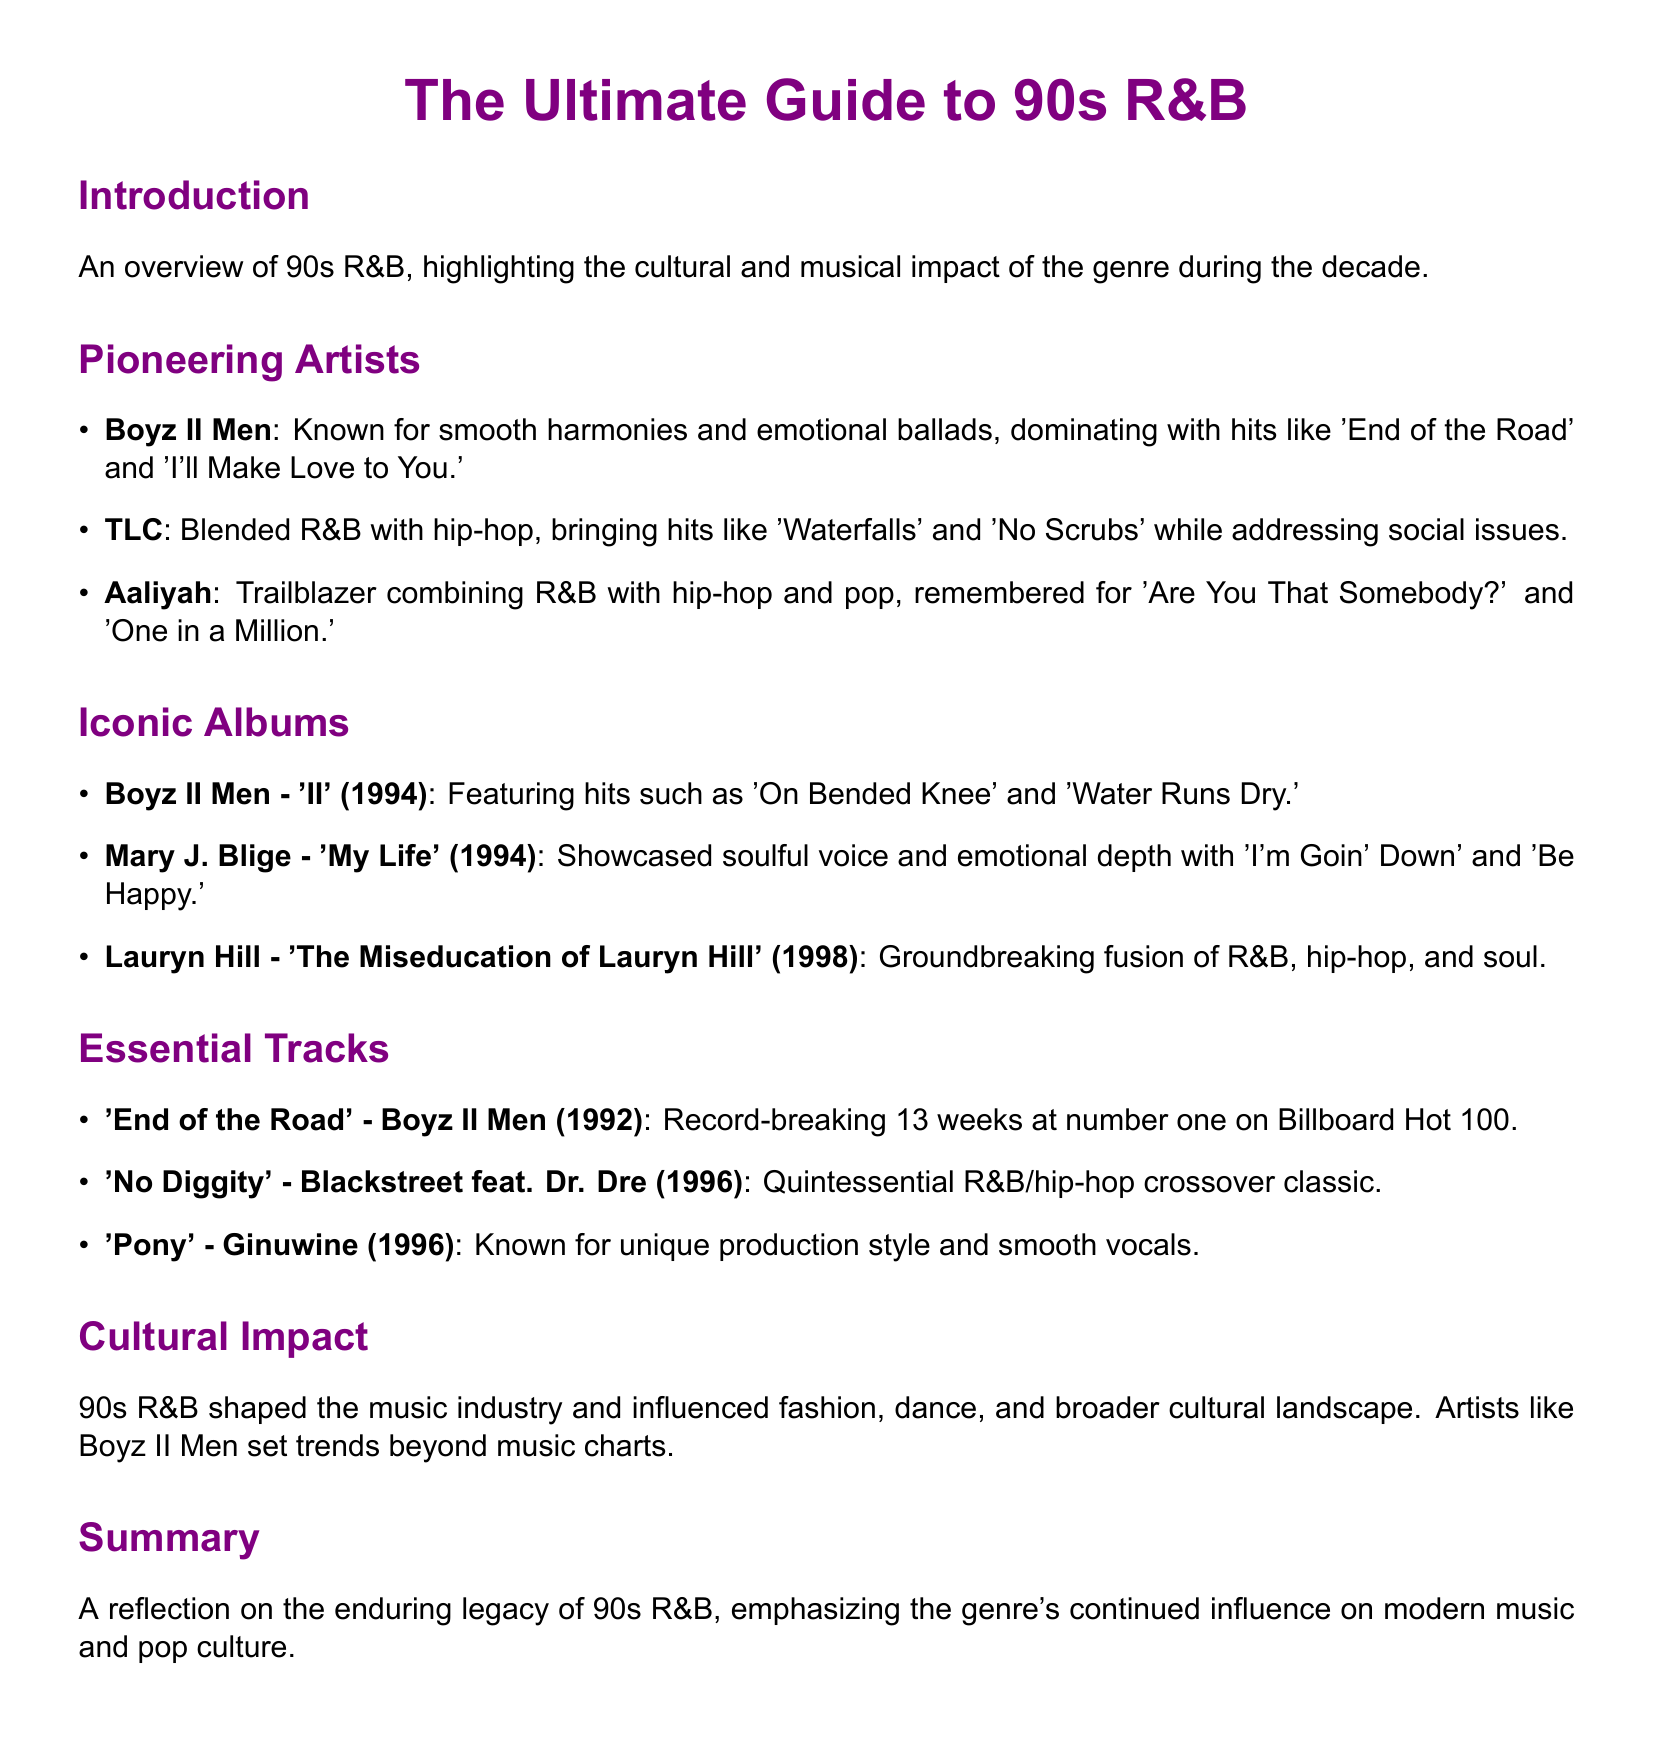What year was Boyz II Men’s album 'II' released? The document states that Boyz II Men released the album 'II' in 1994.
Answer: 1994 Which group is known for the hit 'Waterfalls'? The document mentions that TLC is known for the hit 'Waterfalls'.
Answer: TLC What is a notable track by Aaliyah? The document lists 'Are You That Somebody?' as a notable track by Aaliyah.
Answer: Are You That Somebody? How many weeks did 'End of the Road' spend at number one? The document notes that 'End of the Road' spent a record-breaking 13 weeks at number one.
Answer: 13 weeks What genre did 90s R&B influence beyond music? The document states that 90s R&B influenced fashion, dance, and broader cultural landscape.
Answer: Fashion, dance, and broader cultural landscape Which artist had an album titled 'My Life'? The document indicates that Mary J. Blige had an album titled 'My Life'.
Answer: Mary J. Blige What is the cultural significance of artists like Boyz II Men according to the document? The document highlights that artists like Boyz II Men set trends beyond music charts.
Answer: Set trends beyond music charts What year was 'The Miseducation of Lauryn Hill' released? The document specifies that 'The Miseducation of Lauryn Hill' was released in 1998.
Answer: 1998 Which track is associated with the phrase 'quintessential R&B/hip-hop crossover classic'? The document describes 'No Diggity' as a quintessential R&B/hip-hop crossover classic.
Answer: No Diggity 